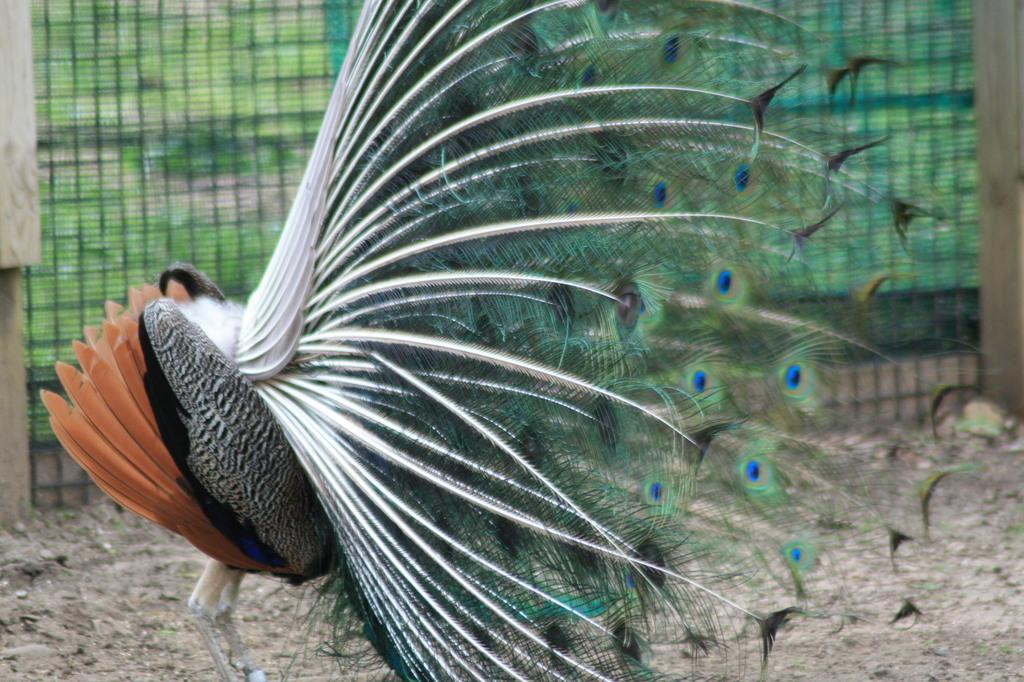What type of animal is in the image? There is a peacock in the image. Where is the peacock located? The peacock is on the ground. What can be seen in the background of the image? There is a grill in the background of the image. How does the peacock compare to the development of the guitar in the image? There is no guitar present in the image, so it is not possible to make a comparison between the peacock and a guitar. 